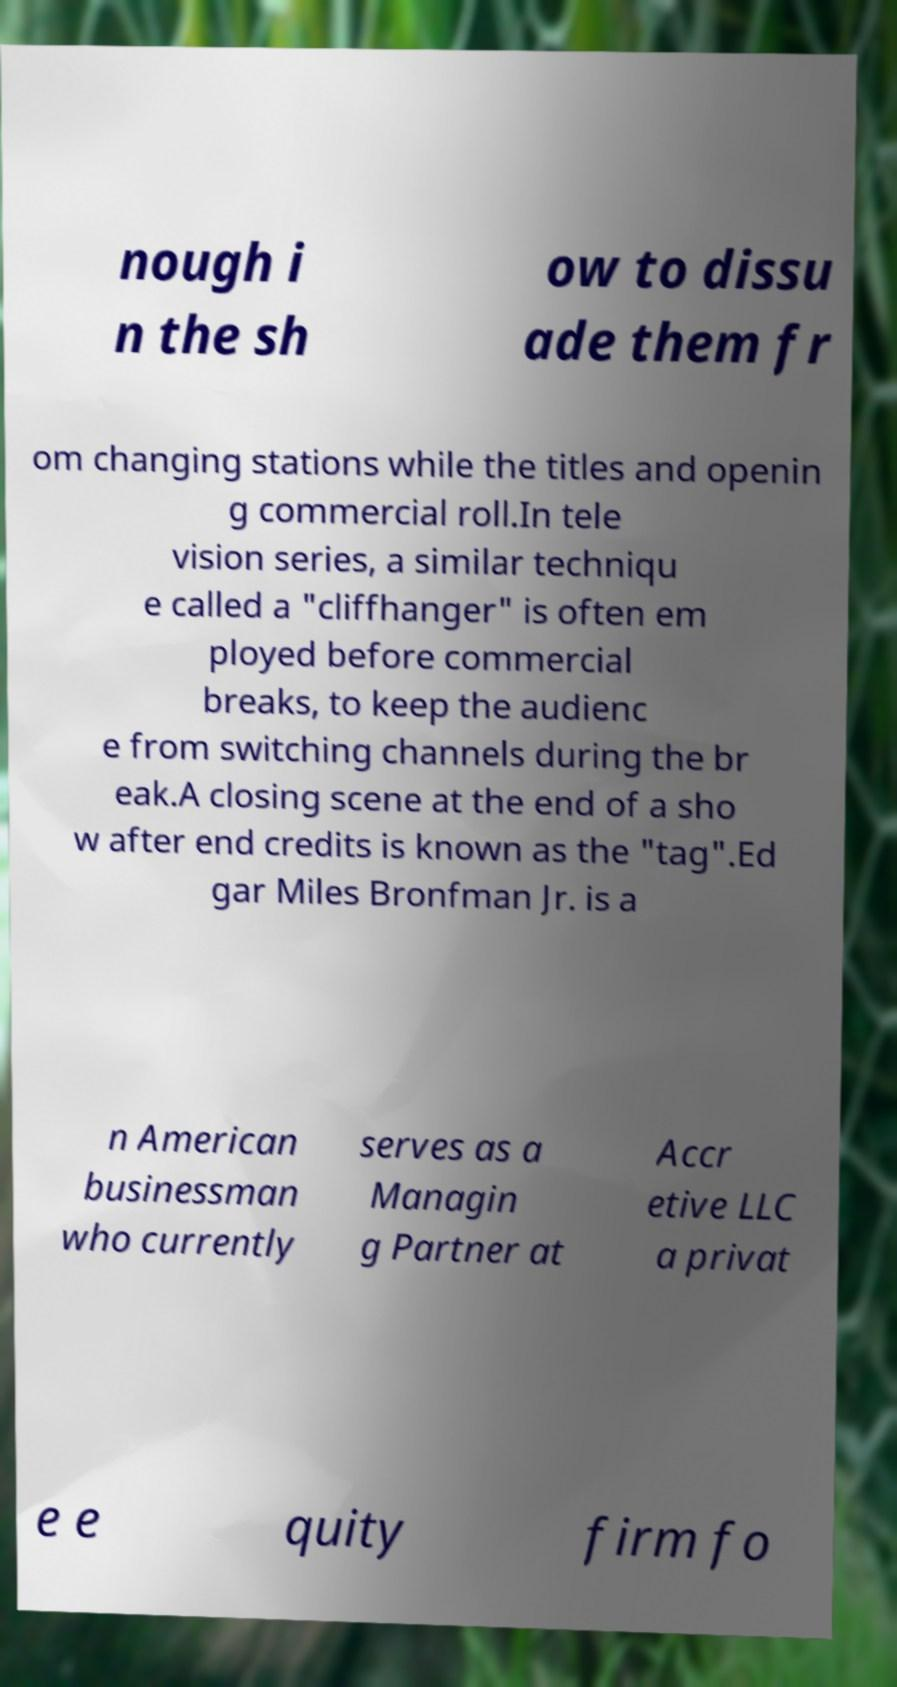I need the written content from this picture converted into text. Can you do that? nough i n the sh ow to dissu ade them fr om changing stations while the titles and openin g commercial roll.In tele vision series, a similar techniqu e called a "cliffhanger" is often em ployed before commercial breaks, to keep the audienc e from switching channels during the br eak.A closing scene at the end of a sho w after end credits is known as the "tag".Ed gar Miles Bronfman Jr. is a n American businessman who currently serves as a Managin g Partner at Accr etive LLC a privat e e quity firm fo 